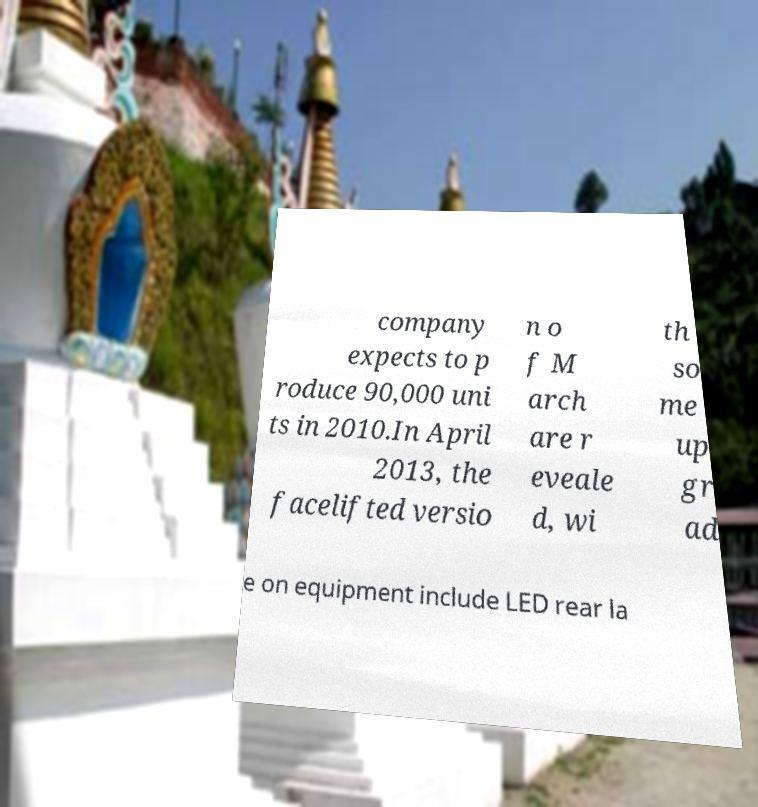What messages or text are displayed in this image? I need them in a readable, typed format. company expects to p roduce 90,000 uni ts in 2010.In April 2013, the facelifted versio n o f M arch are r eveale d, wi th so me up gr ad e on equipment include LED rear la 